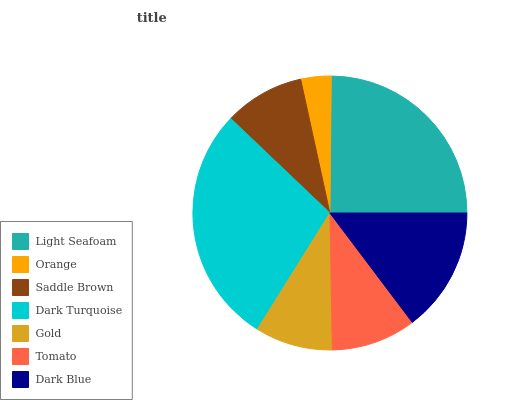Is Orange the minimum?
Answer yes or no. Yes. Is Dark Turquoise the maximum?
Answer yes or no. Yes. Is Saddle Brown the minimum?
Answer yes or no. No. Is Saddle Brown the maximum?
Answer yes or no. No. Is Saddle Brown greater than Orange?
Answer yes or no. Yes. Is Orange less than Saddle Brown?
Answer yes or no. Yes. Is Orange greater than Saddle Brown?
Answer yes or no. No. Is Saddle Brown less than Orange?
Answer yes or no. No. Is Tomato the high median?
Answer yes or no. Yes. Is Tomato the low median?
Answer yes or no. Yes. Is Dark Turquoise the high median?
Answer yes or no. No. Is Dark Blue the low median?
Answer yes or no. No. 